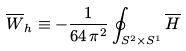Convert formula to latex. <formula><loc_0><loc_0><loc_500><loc_500>\overline { W } _ { h } \equiv - \frac { 1 } { 6 4 \, \pi ^ { 2 } } \oint _ { S ^ { 2 } \times S ^ { 1 } } \overline { H }</formula> 